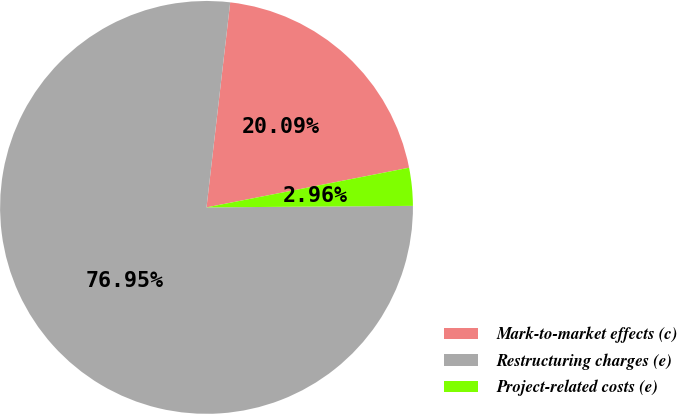<chart> <loc_0><loc_0><loc_500><loc_500><pie_chart><fcel>Mark-to-market effects (c)<fcel>Restructuring charges (e)<fcel>Project-related costs (e)<nl><fcel>20.09%<fcel>76.95%<fcel>2.96%<nl></chart> 